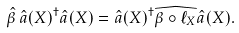Convert formula to latex. <formula><loc_0><loc_0><loc_500><loc_500>\hat { \beta } \, \hat { a } ( X ) ^ { \dagger } \hat { a } ( X ) = \hat { a } ( X ) ^ { \dagger } \widehat { \beta \circ \ell _ { X } } \hat { a } ( X ) .</formula> 